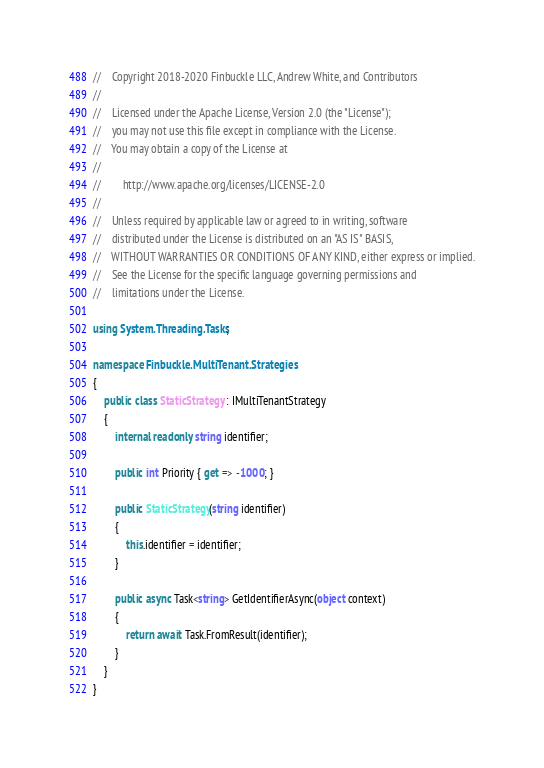Convert code to text. <code><loc_0><loc_0><loc_500><loc_500><_C#_>//    Copyright 2018-2020 Finbuckle LLC, Andrew White, and Contributors
// 
//    Licensed under the Apache License, Version 2.0 (the "License");
//    you may not use this file except in compliance with the License.
//    You may obtain a copy of the License at
// 
//        http://www.apache.org/licenses/LICENSE-2.0
// 
//    Unless required by applicable law or agreed to in writing, software
//    distributed under the License is distributed on an "AS IS" BASIS,
//    WITHOUT WARRANTIES OR CONDITIONS OF ANY KIND, either express or implied.
//    See the License for the specific language governing permissions and
//    limitations under the License.

using System.Threading.Tasks;

namespace Finbuckle.MultiTenant.Strategies
{
    public class StaticStrategy : IMultiTenantStrategy
    {
        internal readonly string identifier;

        public int Priority { get => -1000; }
        
        public StaticStrategy(string identifier)
        {
            this.identifier = identifier;
        }

        public async Task<string> GetIdentifierAsync(object context)
        {
            return await Task.FromResult(identifier);
        }
    }
}</code> 